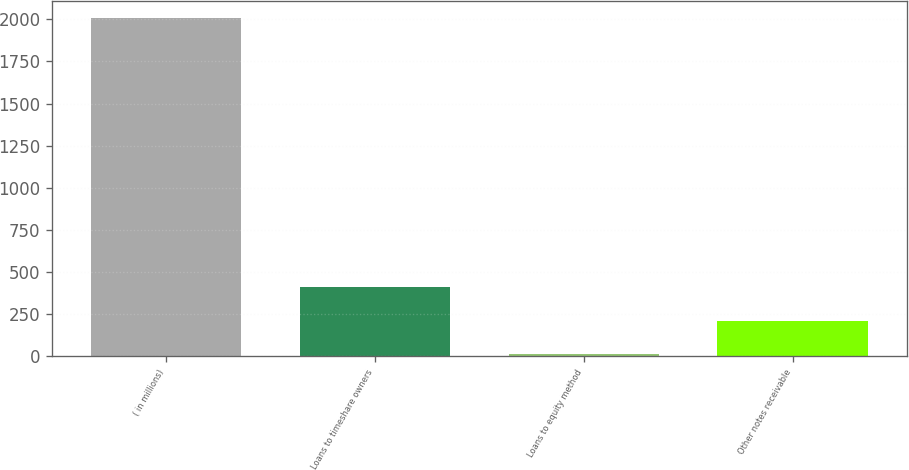Convert chart. <chart><loc_0><loc_0><loc_500><loc_500><bar_chart><fcel>( in millions)<fcel>Loans to timeshare owners<fcel>Loans to equity method<fcel>Other notes receivable<nl><fcel>2009<fcel>409.8<fcel>10<fcel>209.9<nl></chart> 